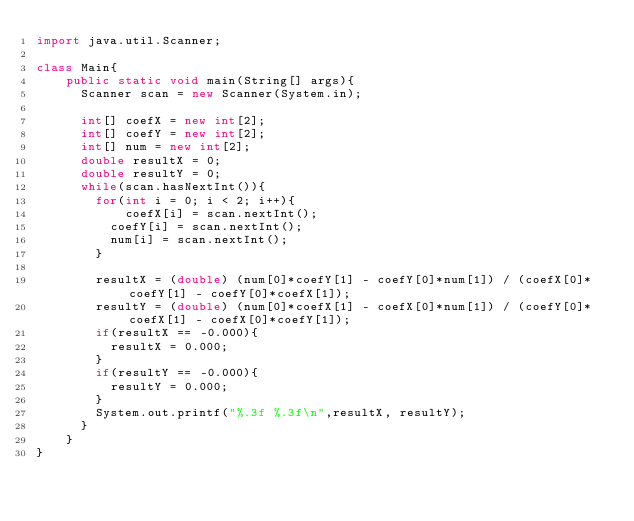<code> <loc_0><loc_0><loc_500><loc_500><_Java_>import java.util.Scanner;

class Main{
    public static void main(String[] args){
    	Scanner scan = new Scanner(System.in);
    	
    	int[] coefX = new int[2];
    	int[] coefY = new int[2];
    	int[] num = new int[2];
    	double resultX = 0;
    	double resultY = 0;
    	while(scan.hasNextInt()){
    		for(int i = 0; i < 2; i++){
        		coefX[i] = scan.nextInt();
    			coefY[i] = scan.nextInt();
    			num[i] = scan.nextInt();
    		}
    		
    		resultX = (double) (num[0]*coefY[1] - coefY[0]*num[1]) / (coefX[0]*coefY[1] - coefY[0]*coefX[1]);
    		resultY = (double) (num[0]*coefX[1] - coefX[0]*num[1]) / (coefY[0]*coefX[1] - coefX[0]*coefY[1]);
    		if(resultX == -0.000){
    			resultX = 0.000;
    		}
    		if(resultY == -0.000){
    			resultY = 0.000;
    		}
    		System.out.printf("%.3f %.3f\n",resultX, resultY);
    	}
    }
}</code> 